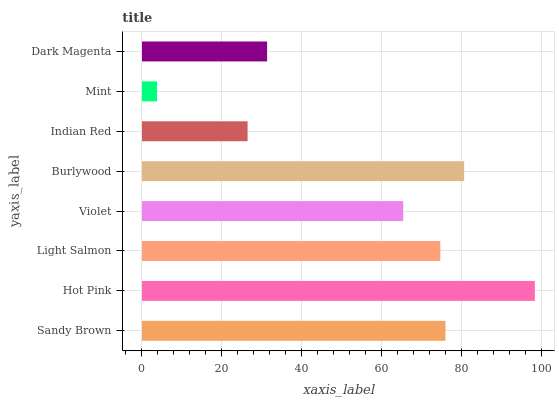Is Mint the minimum?
Answer yes or no. Yes. Is Hot Pink the maximum?
Answer yes or no. Yes. Is Light Salmon the minimum?
Answer yes or no. No. Is Light Salmon the maximum?
Answer yes or no. No. Is Hot Pink greater than Light Salmon?
Answer yes or no. Yes. Is Light Salmon less than Hot Pink?
Answer yes or no. Yes. Is Light Salmon greater than Hot Pink?
Answer yes or no. No. Is Hot Pink less than Light Salmon?
Answer yes or no. No. Is Light Salmon the high median?
Answer yes or no. Yes. Is Violet the low median?
Answer yes or no. Yes. Is Dark Magenta the high median?
Answer yes or no. No. Is Mint the low median?
Answer yes or no. No. 